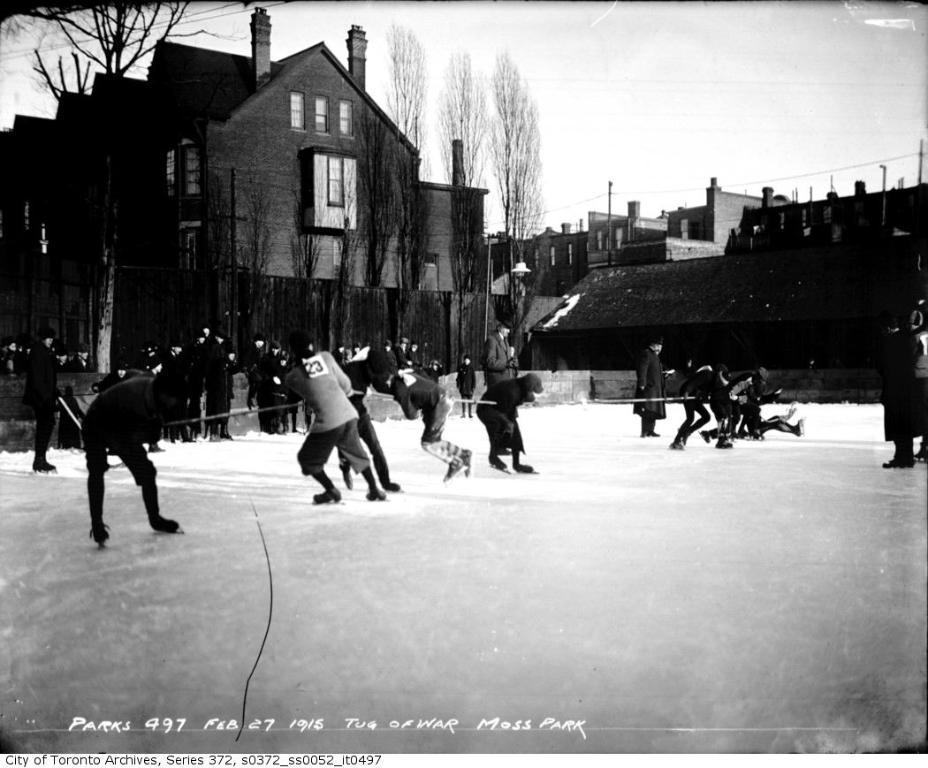Can you describe this image briefly? In this image there are people pulling the rope. At the bottom of the image there is snow on the surface. In the background of the image there are buildings, trees and sky. There is some text at the bottom of the image. 